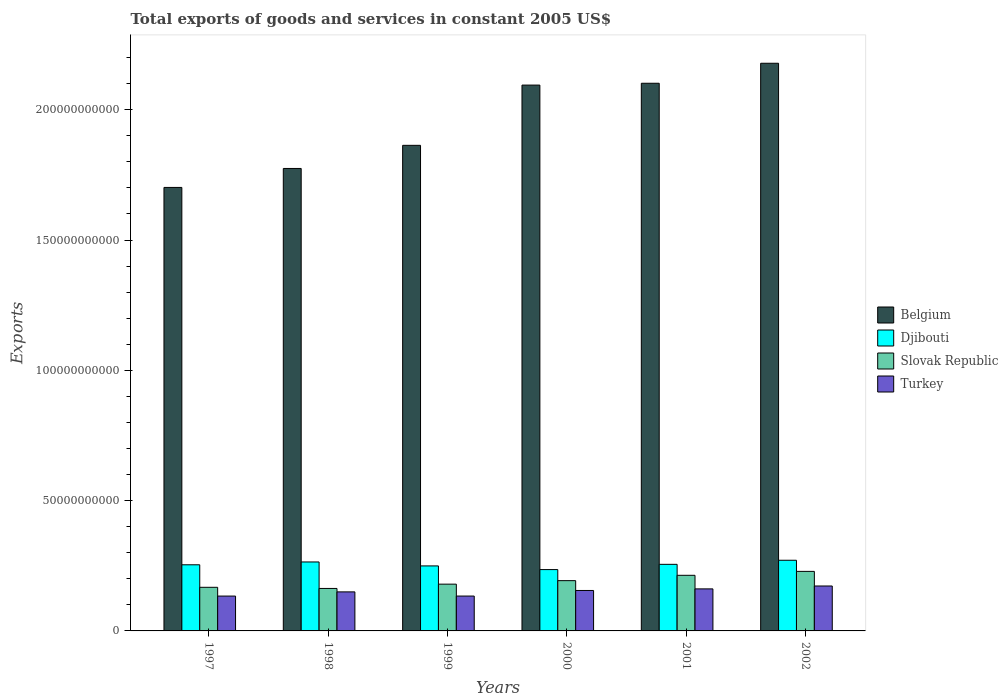Are the number of bars per tick equal to the number of legend labels?
Make the answer very short. Yes. How many bars are there on the 6th tick from the left?
Make the answer very short. 4. In how many cases, is the number of bars for a given year not equal to the number of legend labels?
Your answer should be very brief. 0. What is the total exports of goods and services in Slovak Republic in 1998?
Offer a terse response. 1.63e+1. Across all years, what is the maximum total exports of goods and services in Belgium?
Make the answer very short. 2.18e+11. Across all years, what is the minimum total exports of goods and services in Djibouti?
Ensure brevity in your answer.  2.35e+1. In which year was the total exports of goods and services in Turkey minimum?
Keep it short and to the point. 1997. What is the total total exports of goods and services in Turkey in the graph?
Your answer should be very brief. 9.06e+1. What is the difference between the total exports of goods and services in Slovak Republic in 2000 and that in 2002?
Give a very brief answer. -3.55e+09. What is the difference between the total exports of goods and services in Djibouti in 1997 and the total exports of goods and services in Belgium in 2001?
Offer a very short reply. -1.85e+11. What is the average total exports of goods and services in Belgium per year?
Offer a terse response. 1.95e+11. In the year 2002, what is the difference between the total exports of goods and services in Turkey and total exports of goods and services in Belgium?
Ensure brevity in your answer.  -2.01e+11. What is the ratio of the total exports of goods and services in Djibouti in 1997 to that in 1998?
Your answer should be compact. 0.96. Is the total exports of goods and services in Djibouti in 1999 less than that in 2001?
Provide a short and direct response. Yes. What is the difference between the highest and the second highest total exports of goods and services in Belgium?
Ensure brevity in your answer.  7.67e+09. What is the difference between the highest and the lowest total exports of goods and services in Turkey?
Ensure brevity in your answer.  3.86e+09. Is the sum of the total exports of goods and services in Slovak Republic in 1999 and 2001 greater than the maximum total exports of goods and services in Djibouti across all years?
Your response must be concise. Yes. Is it the case that in every year, the sum of the total exports of goods and services in Djibouti and total exports of goods and services in Belgium is greater than the sum of total exports of goods and services in Slovak Republic and total exports of goods and services in Turkey?
Make the answer very short. No. What does the 1st bar from the left in 1999 represents?
Your answer should be compact. Belgium. Is it the case that in every year, the sum of the total exports of goods and services in Slovak Republic and total exports of goods and services in Djibouti is greater than the total exports of goods and services in Turkey?
Provide a succinct answer. Yes. How many bars are there?
Your answer should be very brief. 24. How many years are there in the graph?
Provide a succinct answer. 6. How many legend labels are there?
Provide a short and direct response. 4. How are the legend labels stacked?
Your answer should be very brief. Vertical. What is the title of the graph?
Provide a succinct answer. Total exports of goods and services in constant 2005 US$. Does "Equatorial Guinea" appear as one of the legend labels in the graph?
Make the answer very short. No. What is the label or title of the X-axis?
Ensure brevity in your answer.  Years. What is the label or title of the Y-axis?
Ensure brevity in your answer.  Exports. What is the Exports in Belgium in 1997?
Offer a very short reply. 1.70e+11. What is the Exports of Djibouti in 1997?
Give a very brief answer. 2.54e+1. What is the Exports of Slovak Republic in 1997?
Offer a terse response. 1.67e+1. What is the Exports of Turkey in 1997?
Your response must be concise. 1.34e+1. What is the Exports in Belgium in 1998?
Offer a very short reply. 1.77e+11. What is the Exports of Djibouti in 1998?
Offer a very short reply. 2.65e+1. What is the Exports of Slovak Republic in 1998?
Offer a very short reply. 1.63e+1. What is the Exports of Turkey in 1998?
Provide a succinct answer. 1.50e+1. What is the Exports in Belgium in 1999?
Provide a short and direct response. 1.86e+11. What is the Exports of Djibouti in 1999?
Keep it short and to the point. 2.49e+1. What is the Exports of Slovak Republic in 1999?
Offer a very short reply. 1.79e+1. What is the Exports in Turkey in 1999?
Make the answer very short. 1.34e+1. What is the Exports in Belgium in 2000?
Your response must be concise. 2.09e+11. What is the Exports of Djibouti in 2000?
Keep it short and to the point. 2.35e+1. What is the Exports in Slovak Republic in 2000?
Give a very brief answer. 1.93e+1. What is the Exports of Turkey in 2000?
Provide a short and direct response. 1.55e+1. What is the Exports of Belgium in 2001?
Your answer should be compact. 2.10e+11. What is the Exports of Djibouti in 2001?
Provide a succinct answer. 2.55e+1. What is the Exports of Slovak Republic in 2001?
Your response must be concise. 2.13e+1. What is the Exports of Turkey in 2001?
Your answer should be very brief. 1.61e+1. What is the Exports in Belgium in 2002?
Your response must be concise. 2.18e+11. What is the Exports in Djibouti in 2002?
Give a very brief answer. 2.71e+1. What is the Exports in Slovak Republic in 2002?
Keep it short and to the point. 2.28e+1. What is the Exports of Turkey in 2002?
Keep it short and to the point. 1.72e+1. Across all years, what is the maximum Exports in Belgium?
Offer a terse response. 2.18e+11. Across all years, what is the maximum Exports in Djibouti?
Your answer should be compact. 2.71e+1. Across all years, what is the maximum Exports of Slovak Republic?
Your response must be concise. 2.28e+1. Across all years, what is the maximum Exports of Turkey?
Give a very brief answer. 1.72e+1. Across all years, what is the minimum Exports of Belgium?
Keep it short and to the point. 1.70e+11. Across all years, what is the minimum Exports in Djibouti?
Offer a terse response. 2.35e+1. Across all years, what is the minimum Exports in Slovak Republic?
Give a very brief answer. 1.63e+1. Across all years, what is the minimum Exports of Turkey?
Your answer should be compact. 1.34e+1. What is the total Exports in Belgium in the graph?
Your answer should be compact. 1.17e+12. What is the total Exports in Djibouti in the graph?
Offer a terse response. 1.53e+11. What is the total Exports of Slovak Republic in the graph?
Your response must be concise. 1.14e+11. What is the total Exports of Turkey in the graph?
Your answer should be very brief. 9.06e+1. What is the difference between the Exports in Belgium in 1997 and that in 1998?
Ensure brevity in your answer.  -7.28e+09. What is the difference between the Exports in Djibouti in 1997 and that in 1998?
Your answer should be compact. -1.09e+09. What is the difference between the Exports of Slovak Republic in 1997 and that in 1998?
Your response must be concise. 4.37e+08. What is the difference between the Exports in Turkey in 1997 and that in 1998?
Keep it short and to the point. -1.60e+09. What is the difference between the Exports of Belgium in 1997 and that in 1999?
Your answer should be very brief. -1.62e+1. What is the difference between the Exports in Djibouti in 1997 and that in 1999?
Keep it short and to the point. 4.30e+08. What is the difference between the Exports of Slovak Republic in 1997 and that in 1999?
Make the answer very short. -1.21e+09. What is the difference between the Exports of Turkey in 1997 and that in 1999?
Your response must be concise. -4.83e+06. What is the difference between the Exports in Belgium in 1997 and that in 2000?
Give a very brief answer. -3.93e+1. What is the difference between the Exports of Djibouti in 1997 and that in 2000?
Keep it short and to the point. 1.84e+09. What is the difference between the Exports of Slovak Republic in 1997 and that in 2000?
Ensure brevity in your answer.  -2.56e+09. What is the difference between the Exports in Turkey in 1997 and that in 2000?
Give a very brief answer. -2.14e+09. What is the difference between the Exports of Belgium in 1997 and that in 2001?
Keep it short and to the point. -4.00e+1. What is the difference between the Exports in Djibouti in 1997 and that in 2001?
Provide a short and direct response. -1.72e+08. What is the difference between the Exports of Slovak Republic in 1997 and that in 2001?
Make the answer very short. -4.61e+09. What is the difference between the Exports in Turkey in 1997 and that in 2001?
Keep it short and to the point. -2.75e+09. What is the difference between the Exports of Belgium in 1997 and that in 2002?
Make the answer very short. -4.76e+1. What is the difference between the Exports in Djibouti in 1997 and that in 2002?
Offer a very short reply. -1.74e+09. What is the difference between the Exports of Slovak Republic in 1997 and that in 2002?
Offer a terse response. -6.11e+09. What is the difference between the Exports in Turkey in 1997 and that in 2002?
Give a very brief answer. -3.86e+09. What is the difference between the Exports of Belgium in 1998 and that in 1999?
Your response must be concise. -8.87e+09. What is the difference between the Exports in Djibouti in 1998 and that in 1999?
Your response must be concise. 1.52e+09. What is the difference between the Exports of Slovak Republic in 1998 and that in 1999?
Provide a succinct answer. -1.65e+09. What is the difference between the Exports of Turkey in 1998 and that in 1999?
Your answer should be compact. 1.60e+09. What is the difference between the Exports of Belgium in 1998 and that in 2000?
Keep it short and to the point. -3.20e+1. What is the difference between the Exports of Djibouti in 1998 and that in 2000?
Make the answer very short. 2.93e+09. What is the difference between the Exports in Slovak Republic in 1998 and that in 2000?
Offer a very short reply. -2.99e+09. What is the difference between the Exports of Turkey in 1998 and that in 2000?
Offer a terse response. -5.39e+08. What is the difference between the Exports of Belgium in 1998 and that in 2001?
Your answer should be compact. -3.27e+1. What is the difference between the Exports of Djibouti in 1998 and that in 2001?
Your answer should be compact. 9.13e+08. What is the difference between the Exports of Slovak Republic in 1998 and that in 2001?
Your response must be concise. -5.04e+09. What is the difference between the Exports of Turkey in 1998 and that in 2001?
Ensure brevity in your answer.  -1.15e+09. What is the difference between the Exports of Belgium in 1998 and that in 2002?
Your answer should be compact. -4.04e+1. What is the difference between the Exports of Djibouti in 1998 and that in 2002?
Your response must be concise. -6.53e+08. What is the difference between the Exports in Slovak Republic in 1998 and that in 2002?
Your answer should be very brief. -6.55e+09. What is the difference between the Exports of Turkey in 1998 and that in 2002?
Offer a terse response. -2.26e+09. What is the difference between the Exports in Belgium in 1999 and that in 2000?
Your answer should be very brief. -2.31e+1. What is the difference between the Exports in Djibouti in 1999 and that in 2000?
Make the answer very short. 1.41e+09. What is the difference between the Exports of Slovak Republic in 1999 and that in 2000?
Your answer should be very brief. -1.34e+09. What is the difference between the Exports of Turkey in 1999 and that in 2000?
Ensure brevity in your answer.  -2.14e+09. What is the difference between the Exports in Belgium in 1999 and that in 2001?
Offer a very short reply. -2.38e+1. What is the difference between the Exports in Djibouti in 1999 and that in 2001?
Your answer should be compact. -6.03e+08. What is the difference between the Exports of Slovak Republic in 1999 and that in 2001?
Offer a very short reply. -3.40e+09. What is the difference between the Exports of Turkey in 1999 and that in 2001?
Give a very brief answer. -2.75e+09. What is the difference between the Exports of Belgium in 1999 and that in 2002?
Make the answer very short. -3.15e+1. What is the difference between the Exports in Djibouti in 1999 and that in 2002?
Ensure brevity in your answer.  -2.17e+09. What is the difference between the Exports of Slovak Republic in 1999 and that in 2002?
Keep it short and to the point. -4.90e+09. What is the difference between the Exports in Turkey in 1999 and that in 2002?
Ensure brevity in your answer.  -3.86e+09. What is the difference between the Exports of Belgium in 2000 and that in 2001?
Provide a succinct answer. -7.06e+08. What is the difference between the Exports of Djibouti in 2000 and that in 2001?
Your response must be concise. -2.02e+09. What is the difference between the Exports in Slovak Republic in 2000 and that in 2001?
Keep it short and to the point. -2.05e+09. What is the difference between the Exports in Turkey in 2000 and that in 2001?
Provide a short and direct response. -6.11e+08. What is the difference between the Exports in Belgium in 2000 and that in 2002?
Offer a terse response. -8.38e+09. What is the difference between the Exports of Djibouti in 2000 and that in 2002?
Offer a terse response. -3.58e+09. What is the difference between the Exports in Slovak Republic in 2000 and that in 2002?
Provide a succinct answer. -3.55e+09. What is the difference between the Exports in Turkey in 2000 and that in 2002?
Make the answer very short. -1.72e+09. What is the difference between the Exports of Belgium in 2001 and that in 2002?
Make the answer very short. -7.67e+09. What is the difference between the Exports in Djibouti in 2001 and that in 2002?
Offer a very short reply. -1.57e+09. What is the difference between the Exports in Slovak Republic in 2001 and that in 2002?
Provide a short and direct response. -1.50e+09. What is the difference between the Exports in Turkey in 2001 and that in 2002?
Provide a succinct answer. -1.11e+09. What is the difference between the Exports in Belgium in 1997 and the Exports in Djibouti in 1998?
Your answer should be compact. 1.44e+11. What is the difference between the Exports of Belgium in 1997 and the Exports of Slovak Republic in 1998?
Offer a terse response. 1.54e+11. What is the difference between the Exports of Belgium in 1997 and the Exports of Turkey in 1998?
Your response must be concise. 1.55e+11. What is the difference between the Exports of Djibouti in 1997 and the Exports of Slovak Republic in 1998?
Offer a terse response. 9.08e+09. What is the difference between the Exports in Djibouti in 1997 and the Exports in Turkey in 1998?
Provide a short and direct response. 1.04e+1. What is the difference between the Exports of Slovak Republic in 1997 and the Exports of Turkey in 1998?
Your answer should be compact. 1.76e+09. What is the difference between the Exports of Belgium in 1997 and the Exports of Djibouti in 1999?
Make the answer very short. 1.45e+11. What is the difference between the Exports in Belgium in 1997 and the Exports in Slovak Republic in 1999?
Offer a very short reply. 1.52e+11. What is the difference between the Exports in Belgium in 1997 and the Exports in Turkey in 1999?
Provide a succinct answer. 1.57e+11. What is the difference between the Exports in Djibouti in 1997 and the Exports in Slovak Republic in 1999?
Your response must be concise. 7.43e+09. What is the difference between the Exports in Djibouti in 1997 and the Exports in Turkey in 1999?
Provide a succinct answer. 1.20e+1. What is the difference between the Exports in Slovak Republic in 1997 and the Exports in Turkey in 1999?
Your answer should be compact. 3.36e+09. What is the difference between the Exports of Belgium in 1997 and the Exports of Djibouti in 2000?
Ensure brevity in your answer.  1.47e+11. What is the difference between the Exports of Belgium in 1997 and the Exports of Slovak Republic in 2000?
Make the answer very short. 1.51e+11. What is the difference between the Exports in Belgium in 1997 and the Exports in Turkey in 2000?
Make the answer very short. 1.55e+11. What is the difference between the Exports of Djibouti in 1997 and the Exports of Slovak Republic in 2000?
Provide a short and direct response. 6.08e+09. What is the difference between the Exports in Djibouti in 1997 and the Exports in Turkey in 2000?
Provide a succinct answer. 9.86e+09. What is the difference between the Exports in Slovak Republic in 1997 and the Exports in Turkey in 2000?
Keep it short and to the point. 1.22e+09. What is the difference between the Exports of Belgium in 1997 and the Exports of Djibouti in 2001?
Provide a succinct answer. 1.45e+11. What is the difference between the Exports of Belgium in 1997 and the Exports of Slovak Republic in 2001?
Give a very brief answer. 1.49e+11. What is the difference between the Exports of Belgium in 1997 and the Exports of Turkey in 2001?
Keep it short and to the point. 1.54e+11. What is the difference between the Exports in Djibouti in 1997 and the Exports in Slovak Republic in 2001?
Your answer should be very brief. 4.03e+09. What is the difference between the Exports in Djibouti in 1997 and the Exports in Turkey in 2001?
Your answer should be compact. 9.25e+09. What is the difference between the Exports of Slovak Republic in 1997 and the Exports of Turkey in 2001?
Provide a succinct answer. 6.08e+08. What is the difference between the Exports in Belgium in 1997 and the Exports in Djibouti in 2002?
Give a very brief answer. 1.43e+11. What is the difference between the Exports in Belgium in 1997 and the Exports in Slovak Republic in 2002?
Your answer should be very brief. 1.47e+11. What is the difference between the Exports in Belgium in 1997 and the Exports in Turkey in 2002?
Your response must be concise. 1.53e+11. What is the difference between the Exports in Djibouti in 1997 and the Exports in Slovak Republic in 2002?
Your answer should be very brief. 2.53e+09. What is the difference between the Exports of Djibouti in 1997 and the Exports of Turkey in 2002?
Provide a short and direct response. 8.14e+09. What is the difference between the Exports of Slovak Republic in 1997 and the Exports of Turkey in 2002?
Provide a short and direct response. -5.03e+08. What is the difference between the Exports of Belgium in 1998 and the Exports of Djibouti in 1999?
Your answer should be compact. 1.53e+11. What is the difference between the Exports in Belgium in 1998 and the Exports in Slovak Republic in 1999?
Offer a terse response. 1.60e+11. What is the difference between the Exports of Belgium in 1998 and the Exports of Turkey in 1999?
Give a very brief answer. 1.64e+11. What is the difference between the Exports in Djibouti in 1998 and the Exports in Slovak Republic in 1999?
Offer a very short reply. 8.51e+09. What is the difference between the Exports in Djibouti in 1998 and the Exports in Turkey in 1999?
Offer a terse response. 1.31e+1. What is the difference between the Exports of Slovak Republic in 1998 and the Exports of Turkey in 1999?
Give a very brief answer. 2.92e+09. What is the difference between the Exports of Belgium in 1998 and the Exports of Djibouti in 2000?
Give a very brief answer. 1.54e+11. What is the difference between the Exports in Belgium in 1998 and the Exports in Slovak Republic in 2000?
Provide a succinct answer. 1.58e+11. What is the difference between the Exports of Belgium in 1998 and the Exports of Turkey in 2000?
Provide a succinct answer. 1.62e+11. What is the difference between the Exports in Djibouti in 1998 and the Exports in Slovak Republic in 2000?
Provide a short and direct response. 7.17e+09. What is the difference between the Exports in Djibouti in 1998 and the Exports in Turkey in 2000?
Provide a short and direct response. 1.09e+1. What is the difference between the Exports of Slovak Republic in 1998 and the Exports of Turkey in 2000?
Provide a succinct answer. 7.81e+08. What is the difference between the Exports in Belgium in 1998 and the Exports in Djibouti in 2001?
Give a very brief answer. 1.52e+11. What is the difference between the Exports in Belgium in 1998 and the Exports in Slovak Republic in 2001?
Give a very brief answer. 1.56e+11. What is the difference between the Exports in Belgium in 1998 and the Exports in Turkey in 2001?
Your answer should be compact. 1.61e+11. What is the difference between the Exports of Djibouti in 1998 and the Exports of Slovak Republic in 2001?
Provide a succinct answer. 5.12e+09. What is the difference between the Exports of Djibouti in 1998 and the Exports of Turkey in 2001?
Make the answer very short. 1.03e+1. What is the difference between the Exports in Slovak Republic in 1998 and the Exports in Turkey in 2001?
Offer a very short reply. 1.71e+08. What is the difference between the Exports in Belgium in 1998 and the Exports in Djibouti in 2002?
Keep it short and to the point. 1.50e+11. What is the difference between the Exports of Belgium in 1998 and the Exports of Slovak Republic in 2002?
Keep it short and to the point. 1.55e+11. What is the difference between the Exports of Belgium in 1998 and the Exports of Turkey in 2002?
Give a very brief answer. 1.60e+11. What is the difference between the Exports of Djibouti in 1998 and the Exports of Slovak Republic in 2002?
Your answer should be compact. 3.62e+09. What is the difference between the Exports in Djibouti in 1998 and the Exports in Turkey in 2002?
Ensure brevity in your answer.  9.22e+09. What is the difference between the Exports of Slovak Republic in 1998 and the Exports of Turkey in 2002?
Offer a very short reply. -9.40e+08. What is the difference between the Exports of Belgium in 1999 and the Exports of Djibouti in 2000?
Ensure brevity in your answer.  1.63e+11. What is the difference between the Exports in Belgium in 1999 and the Exports in Slovak Republic in 2000?
Offer a terse response. 1.67e+11. What is the difference between the Exports in Belgium in 1999 and the Exports in Turkey in 2000?
Offer a terse response. 1.71e+11. What is the difference between the Exports in Djibouti in 1999 and the Exports in Slovak Republic in 2000?
Make the answer very short. 5.65e+09. What is the difference between the Exports of Djibouti in 1999 and the Exports of Turkey in 2000?
Ensure brevity in your answer.  9.43e+09. What is the difference between the Exports of Slovak Republic in 1999 and the Exports of Turkey in 2000?
Keep it short and to the point. 2.43e+09. What is the difference between the Exports of Belgium in 1999 and the Exports of Djibouti in 2001?
Provide a succinct answer. 1.61e+11. What is the difference between the Exports in Belgium in 1999 and the Exports in Slovak Republic in 2001?
Ensure brevity in your answer.  1.65e+11. What is the difference between the Exports in Belgium in 1999 and the Exports in Turkey in 2001?
Keep it short and to the point. 1.70e+11. What is the difference between the Exports in Djibouti in 1999 and the Exports in Slovak Republic in 2001?
Offer a terse response. 3.60e+09. What is the difference between the Exports of Djibouti in 1999 and the Exports of Turkey in 2001?
Provide a succinct answer. 8.82e+09. What is the difference between the Exports in Slovak Republic in 1999 and the Exports in Turkey in 2001?
Your answer should be compact. 1.82e+09. What is the difference between the Exports in Belgium in 1999 and the Exports in Djibouti in 2002?
Offer a very short reply. 1.59e+11. What is the difference between the Exports in Belgium in 1999 and the Exports in Slovak Republic in 2002?
Offer a terse response. 1.63e+11. What is the difference between the Exports in Belgium in 1999 and the Exports in Turkey in 2002?
Make the answer very short. 1.69e+11. What is the difference between the Exports in Djibouti in 1999 and the Exports in Slovak Republic in 2002?
Keep it short and to the point. 2.10e+09. What is the difference between the Exports in Djibouti in 1999 and the Exports in Turkey in 2002?
Provide a succinct answer. 7.71e+09. What is the difference between the Exports in Slovak Republic in 1999 and the Exports in Turkey in 2002?
Ensure brevity in your answer.  7.08e+08. What is the difference between the Exports in Belgium in 2000 and the Exports in Djibouti in 2001?
Your answer should be very brief. 1.84e+11. What is the difference between the Exports in Belgium in 2000 and the Exports in Slovak Republic in 2001?
Ensure brevity in your answer.  1.88e+11. What is the difference between the Exports of Belgium in 2000 and the Exports of Turkey in 2001?
Give a very brief answer. 1.93e+11. What is the difference between the Exports of Djibouti in 2000 and the Exports of Slovak Republic in 2001?
Offer a very short reply. 2.19e+09. What is the difference between the Exports of Djibouti in 2000 and the Exports of Turkey in 2001?
Offer a terse response. 7.40e+09. What is the difference between the Exports of Slovak Republic in 2000 and the Exports of Turkey in 2001?
Offer a terse response. 3.16e+09. What is the difference between the Exports of Belgium in 2000 and the Exports of Djibouti in 2002?
Ensure brevity in your answer.  1.82e+11. What is the difference between the Exports in Belgium in 2000 and the Exports in Slovak Republic in 2002?
Your answer should be very brief. 1.87e+11. What is the difference between the Exports of Belgium in 2000 and the Exports of Turkey in 2002?
Provide a succinct answer. 1.92e+11. What is the difference between the Exports of Djibouti in 2000 and the Exports of Slovak Republic in 2002?
Ensure brevity in your answer.  6.87e+08. What is the difference between the Exports in Djibouti in 2000 and the Exports in Turkey in 2002?
Offer a terse response. 6.29e+09. What is the difference between the Exports in Slovak Republic in 2000 and the Exports in Turkey in 2002?
Your answer should be very brief. 2.05e+09. What is the difference between the Exports of Belgium in 2001 and the Exports of Djibouti in 2002?
Offer a terse response. 1.83e+11. What is the difference between the Exports in Belgium in 2001 and the Exports in Slovak Republic in 2002?
Provide a succinct answer. 1.87e+11. What is the difference between the Exports in Belgium in 2001 and the Exports in Turkey in 2002?
Your answer should be compact. 1.93e+11. What is the difference between the Exports of Djibouti in 2001 and the Exports of Slovak Republic in 2002?
Your response must be concise. 2.70e+09. What is the difference between the Exports of Djibouti in 2001 and the Exports of Turkey in 2002?
Provide a short and direct response. 8.31e+09. What is the difference between the Exports in Slovak Republic in 2001 and the Exports in Turkey in 2002?
Provide a succinct answer. 4.10e+09. What is the average Exports of Belgium per year?
Provide a succinct answer. 1.95e+11. What is the average Exports in Djibouti per year?
Your answer should be very brief. 2.55e+1. What is the average Exports in Slovak Republic per year?
Ensure brevity in your answer.  1.91e+1. What is the average Exports in Turkey per year?
Ensure brevity in your answer.  1.51e+1. In the year 1997, what is the difference between the Exports in Belgium and Exports in Djibouti?
Keep it short and to the point. 1.45e+11. In the year 1997, what is the difference between the Exports of Belgium and Exports of Slovak Republic?
Provide a short and direct response. 1.53e+11. In the year 1997, what is the difference between the Exports in Belgium and Exports in Turkey?
Offer a terse response. 1.57e+11. In the year 1997, what is the difference between the Exports in Djibouti and Exports in Slovak Republic?
Your answer should be very brief. 8.64e+09. In the year 1997, what is the difference between the Exports of Djibouti and Exports of Turkey?
Make the answer very short. 1.20e+1. In the year 1997, what is the difference between the Exports in Slovak Republic and Exports in Turkey?
Make the answer very short. 3.36e+09. In the year 1998, what is the difference between the Exports of Belgium and Exports of Djibouti?
Your answer should be very brief. 1.51e+11. In the year 1998, what is the difference between the Exports in Belgium and Exports in Slovak Republic?
Provide a succinct answer. 1.61e+11. In the year 1998, what is the difference between the Exports in Belgium and Exports in Turkey?
Provide a succinct answer. 1.62e+11. In the year 1998, what is the difference between the Exports in Djibouti and Exports in Slovak Republic?
Your response must be concise. 1.02e+1. In the year 1998, what is the difference between the Exports in Djibouti and Exports in Turkey?
Keep it short and to the point. 1.15e+1. In the year 1998, what is the difference between the Exports of Slovak Republic and Exports of Turkey?
Offer a very short reply. 1.32e+09. In the year 1999, what is the difference between the Exports in Belgium and Exports in Djibouti?
Offer a terse response. 1.61e+11. In the year 1999, what is the difference between the Exports in Belgium and Exports in Slovak Republic?
Keep it short and to the point. 1.68e+11. In the year 1999, what is the difference between the Exports of Belgium and Exports of Turkey?
Your answer should be compact. 1.73e+11. In the year 1999, what is the difference between the Exports in Djibouti and Exports in Slovak Republic?
Your answer should be compact. 7.00e+09. In the year 1999, what is the difference between the Exports of Djibouti and Exports of Turkey?
Provide a succinct answer. 1.16e+1. In the year 1999, what is the difference between the Exports of Slovak Republic and Exports of Turkey?
Provide a succinct answer. 4.57e+09. In the year 2000, what is the difference between the Exports in Belgium and Exports in Djibouti?
Offer a terse response. 1.86e+11. In the year 2000, what is the difference between the Exports of Belgium and Exports of Slovak Republic?
Ensure brevity in your answer.  1.90e+11. In the year 2000, what is the difference between the Exports of Belgium and Exports of Turkey?
Give a very brief answer. 1.94e+11. In the year 2000, what is the difference between the Exports in Djibouti and Exports in Slovak Republic?
Your answer should be very brief. 4.24e+09. In the year 2000, what is the difference between the Exports in Djibouti and Exports in Turkey?
Provide a succinct answer. 8.01e+09. In the year 2000, what is the difference between the Exports of Slovak Republic and Exports of Turkey?
Make the answer very short. 3.77e+09. In the year 2001, what is the difference between the Exports of Belgium and Exports of Djibouti?
Provide a short and direct response. 1.85e+11. In the year 2001, what is the difference between the Exports in Belgium and Exports in Slovak Republic?
Give a very brief answer. 1.89e+11. In the year 2001, what is the difference between the Exports in Belgium and Exports in Turkey?
Ensure brevity in your answer.  1.94e+11. In the year 2001, what is the difference between the Exports of Djibouti and Exports of Slovak Republic?
Your answer should be compact. 4.21e+09. In the year 2001, what is the difference between the Exports in Djibouti and Exports in Turkey?
Provide a short and direct response. 9.42e+09. In the year 2001, what is the difference between the Exports in Slovak Republic and Exports in Turkey?
Your response must be concise. 5.21e+09. In the year 2002, what is the difference between the Exports of Belgium and Exports of Djibouti?
Provide a succinct answer. 1.91e+11. In the year 2002, what is the difference between the Exports of Belgium and Exports of Slovak Republic?
Make the answer very short. 1.95e+11. In the year 2002, what is the difference between the Exports of Belgium and Exports of Turkey?
Your answer should be very brief. 2.01e+11. In the year 2002, what is the difference between the Exports of Djibouti and Exports of Slovak Republic?
Your answer should be compact. 4.27e+09. In the year 2002, what is the difference between the Exports in Djibouti and Exports in Turkey?
Keep it short and to the point. 9.87e+09. In the year 2002, what is the difference between the Exports in Slovak Republic and Exports in Turkey?
Give a very brief answer. 5.61e+09. What is the ratio of the Exports in Djibouti in 1997 to that in 1998?
Keep it short and to the point. 0.96. What is the ratio of the Exports in Slovak Republic in 1997 to that in 1998?
Make the answer very short. 1.03. What is the ratio of the Exports of Turkey in 1997 to that in 1998?
Give a very brief answer. 0.89. What is the ratio of the Exports in Belgium in 1997 to that in 1999?
Your answer should be very brief. 0.91. What is the ratio of the Exports of Djibouti in 1997 to that in 1999?
Offer a terse response. 1.02. What is the ratio of the Exports in Slovak Republic in 1997 to that in 1999?
Provide a succinct answer. 0.93. What is the ratio of the Exports in Turkey in 1997 to that in 1999?
Offer a terse response. 1. What is the ratio of the Exports in Belgium in 1997 to that in 2000?
Ensure brevity in your answer.  0.81. What is the ratio of the Exports in Djibouti in 1997 to that in 2000?
Your answer should be very brief. 1.08. What is the ratio of the Exports of Slovak Republic in 1997 to that in 2000?
Your answer should be very brief. 0.87. What is the ratio of the Exports of Turkey in 1997 to that in 2000?
Make the answer very short. 0.86. What is the ratio of the Exports of Belgium in 1997 to that in 2001?
Your response must be concise. 0.81. What is the ratio of the Exports of Slovak Republic in 1997 to that in 2001?
Offer a terse response. 0.78. What is the ratio of the Exports in Turkey in 1997 to that in 2001?
Offer a very short reply. 0.83. What is the ratio of the Exports in Belgium in 1997 to that in 2002?
Offer a terse response. 0.78. What is the ratio of the Exports in Djibouti in 1997 to that in 2002?
Your response must be concise. 0.94. What is the ratio of the Exports of Slovak Republic in 1997 to that in 2002?
Make the answer very short. 0.73. What is the ratio of the Exports in Turkey in 1997 to that in 2002?
Provide a succinct answer. 0.78. What is the ratio of the Exports in Belgium in 1998 to that in 1999?
Offer a very short reply. 0.95. What is the ratio of the Exports of Djibouti in 1998 to that in 1999?
Your answer should be very brief. 1.06. What is the ratio of the Exports of Slovak Republic in 1998 to that in 1999?
Make the answer very short. 0.91. What is the ratio of the Exports of Turkey in 1998 to that in 1999?
Your response must be concise. 1.12. What is the ratio of the Exports of Belgium in 1998 to that in 2000?
Provide a succinct answer. 0.85. What is the ratio of the Exports in Djibouti in 1998 to that in 2000?
Provide a short and direct response. 1.12. What is the ratio of the Exports in Slovak Republic in 1998 to that in 2000?
Make the answer very short. 0.84. What is the ratio of the Exports of Turkey in 1998 to that in 2000?
Your answer should be very brief. 0.97. What is the ratio of the Exports of Belgium in 1998 to that in 2001?
Offer a very short reply. 0.84. What is the ratio of the Exports of Djibouti in 1998 to that in 2001?
Your answer should be compact. 1.04. What is the ratio of the Exports of Slovak Republic in 1998 to that in 2001?
Offer a very short reply. 0.76. What is the ratio of the Exports in Turkey in 1998 to that in 2001?
Offer a terse response. 0.93. What is the ratio of the Exports of Belgium in 1998 to that in 2002?
Give a very brief answer. 0.81. What is the ratio of the Exports in Djibouti in 1998 to that in 2002?
Make the answer very short. 0.98. What is the ratio of the Exports in Slovak Republic in 1998 to that in 2002?
Give a very brief answer. 0.71. What is the ratio of the Exports of Turkey in 1998 to that in 2002?
Give a very brief answer. 0.87. What is the ratio of the Exports in Belgium in 1999 to that in 2000?
Give a very brief answer. 0.89. What is the ratio of the Exports of Djibouti in 1999 to that in 2000?
Keep it short and to the point. 1.06. What is the ratio of the Exports in Slovak Republic in 1999 to that in 2000?
Make the answer very short. 0.93. What is the ratio of the Exports in Turkey in 1999 to that in 2000?
Provide a succinct answer. 0.86. What is the ratio of the Exports of Belgium in 1999 to that in 2001?
Give a very brief answer. 0.89. What is the ratio of the Exports of Djibouti in 1999 to that in 2001?
Ensure brevity in your answer.  0.98. What is the ratio of the Exports in Slovak Republic in 1999 to that in 2001?
Offer a terse response. 0.84. What is the ratio of the Exports in Turkey in 1999 to that in 2001?
Keep it short and to the point. 0.83. What is the ratio of the Exports of Belgium in 1999 to that in 2002?
Make the answer very short. 0.86. What is the ratio of the Exports in Slovak Republic in 1999 to that in 2002?
Your answer should be compact. 0.79. What is the ratio of the Exports of Turkey in 1999 to that in 2002?
Your answer should be compact. 0.78. What is the ratio of the Exports of Belgium in 2000 to that in 2001?
Your answer should be very brief. 1. What is the ratio of the Exports of Djibouti in 2000 to that in 2001?
Your answer should be compact. 0.92. What is the ratio of the Exports in Slovak Republic in 2000 to that in 2001?
Ensure brevity in your answer.  0.9. What is the ratio of the Exports in Turkey in 2000 to that in 2001?
Your answer should be very brief. 0.96. What is the ratio of the Exports of Belgium in 2000 to that in 2002?
Provide a short and direct response. 0.96. What is the ratio of the Exports in Djibouti in 2000 to that in 2002?
Your answer should be very brief. 0.87. What is the ratio of the Exports in Slovak Republic in 2000 to that in 2002?
Offer a very short reply. 0.84. What is the ratio of the Exports in Turkey in 2000 to that in 2002?
Make the answer very short. 0.9. What is the ratio of the Exports of Belgium in 2001 to that in 2002?
Give a very brief answer. 0.96. What is the ratio of the Exports of Djibouti in 2001 to that in 2002?
Ensure brevity in your answer.  0.94. What is the ratio of the Exports in Slovak Republic in 2001 to that in 2002?
Keep it short and to the point. 0.93. What is the ratio of the Exports in Turkey in 2001 to that in 2002?
Offer a very short reply. 0.94. What is the difference between the highest and the second highest Exports of Belgium?
Give a very brief answer. 7.67e+09. What is the difference between the highest and the second highest Exports in Djibouti?
Offer a very short reply. 6.53e+08. What is the difference between the highest and the second highest Exports of Slovak Republic?
Your response must be concise. 1.50e+09. What is the difference between the highest and the second highest Exports in Turkey?
Your answer should be compact. 1.11e+09. What is the difference between the highest and the lowest Exports in Belgium?
Ensure brevity in your answer.  4.76e+1. What is the difference between the highest and the lowest Exports of Djibouti?
Provide a succinct answer. 3.58e+09. What is the difference between the highest and the lowest Exports of Slovak Republic?
Give a very brief answer. 6.55e+09. What is the difference between the highest and the lowest Exports of Turkey?
Your answer should be compact. 3.86e+09. 